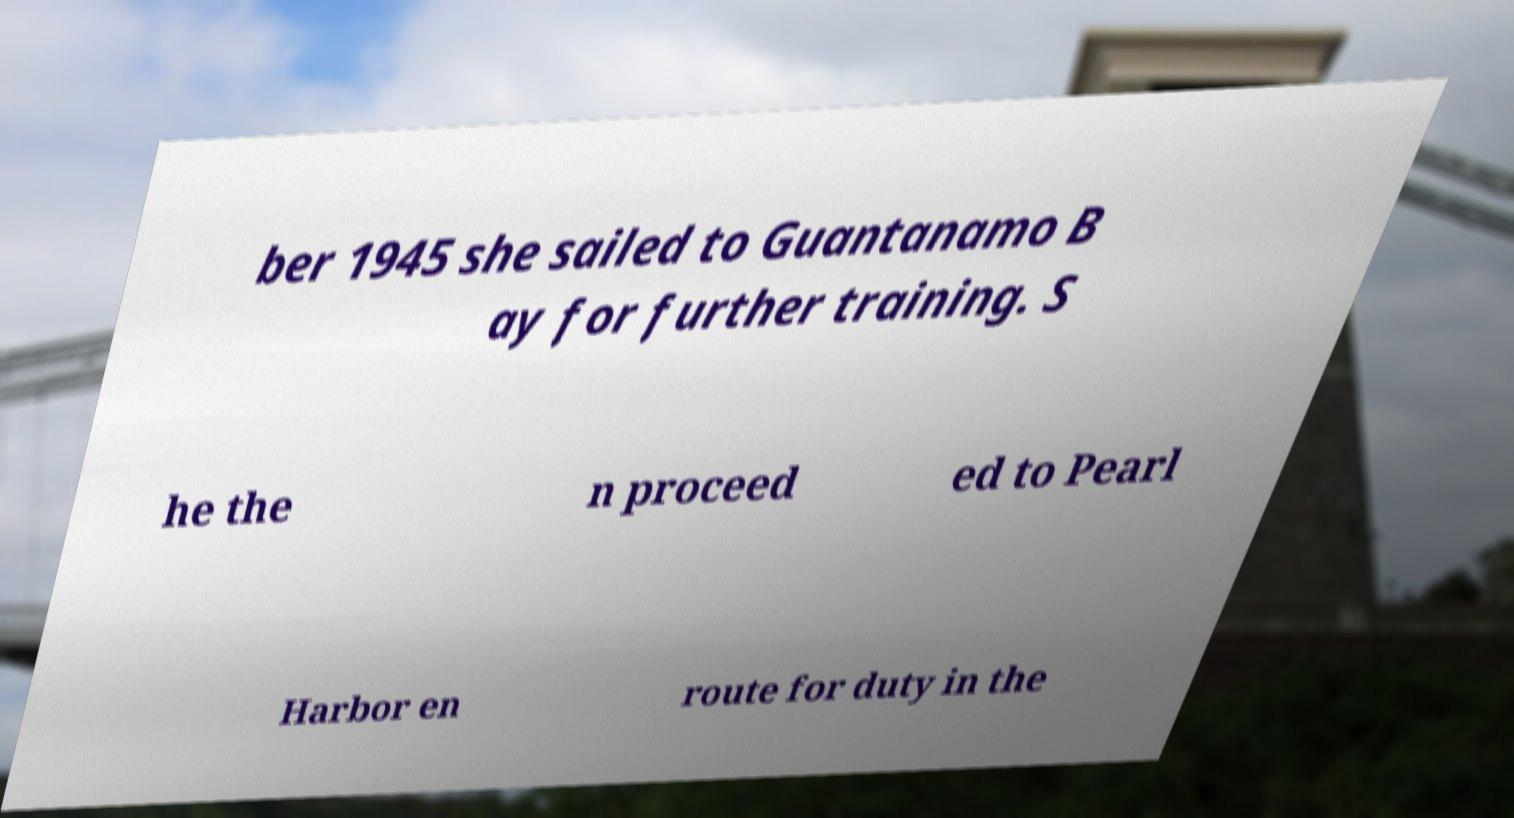Could you extract and type out the text from this image? ber 1945 she sailed to Guantanamo B ay for further training. S he the n proceed ed to Pearl Harbor en route for duty in the 